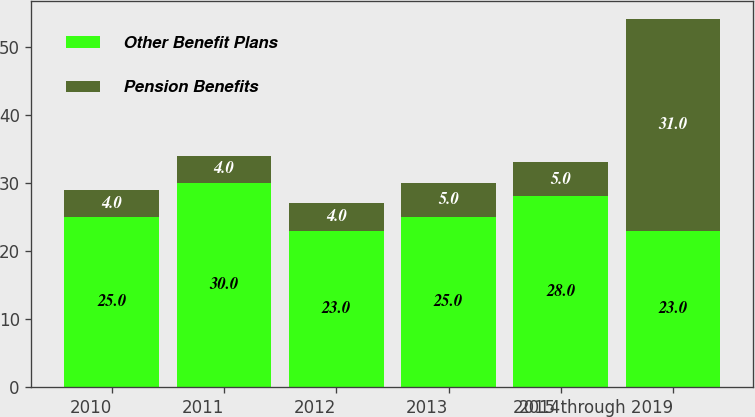Convert chart to OTSL. <chart><loc_0><loc_0><loc_500><loc_500><stacked_bar_chart><ecel><fcel>2010<fcel>2011<fcel>2012<fcel>2013<fcel>2014<fcel>2015 through 2019<nl><fcel>Other Benefit Plans<fcel>25<fcel>30<fcel>23<fcel>25<fcel>28<fcel>23<nl><fcel>Pension Benefits<fcel>4<fcel>4<fcel>4<fcel>5<fcel>5<fcel>31<nl></chart> 